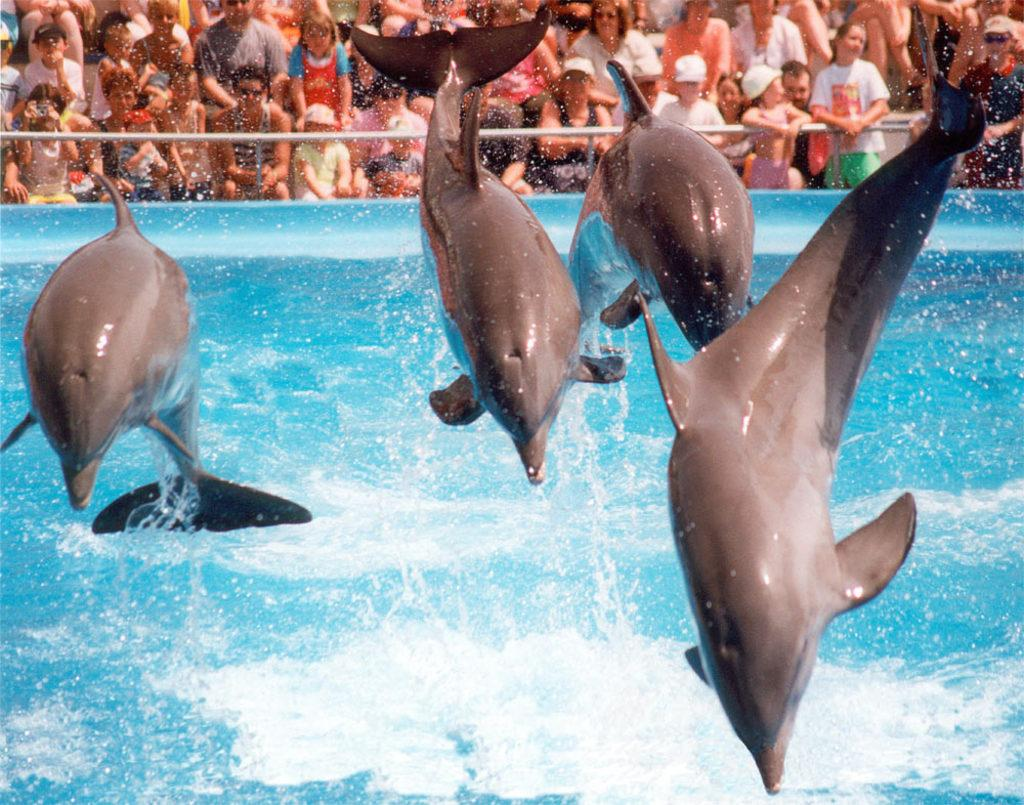What animals are featured in the image? There are dolphins in the image. What are the dolphins doing in the image? The dolphins are jumping into the water. Can you describe the people in the background of the image? The people are near an iron railing. What type of wine is being served to the cattle in the image? There are no cattle or wine present in the image; it features dolphins jumping into the water and people near an iron railing. 